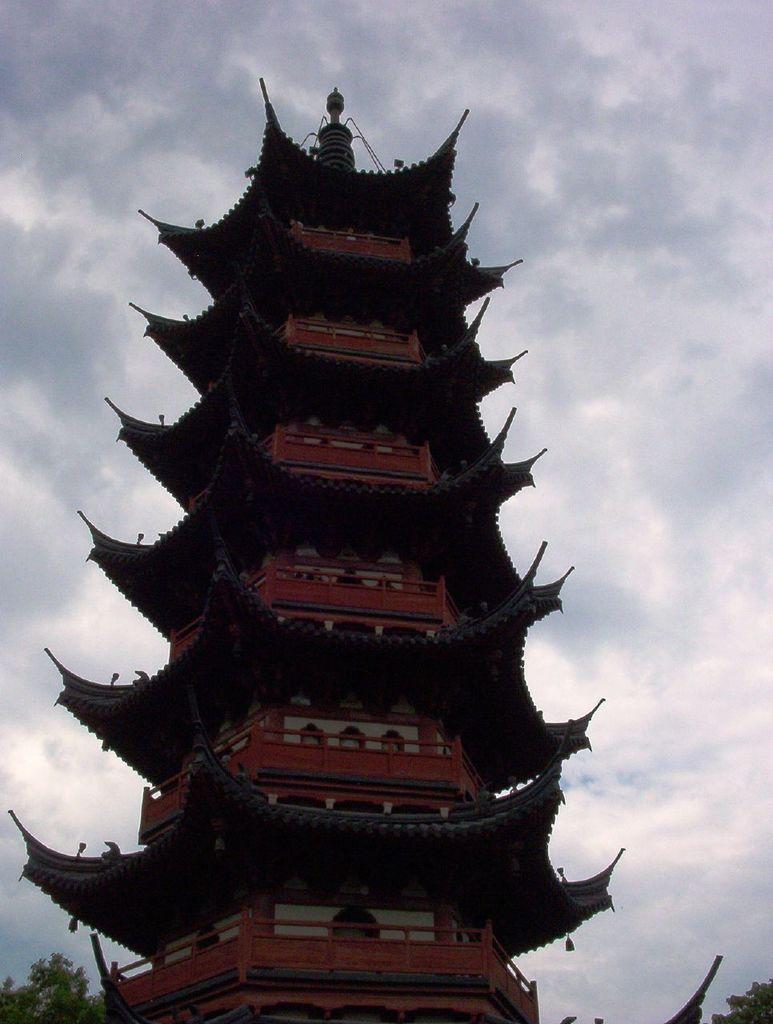Can you describe this image briefly? In this image, we can see a building. We can see some trees on the left and right. We can also see the sky with clouds. We can see an object at the bottom. 